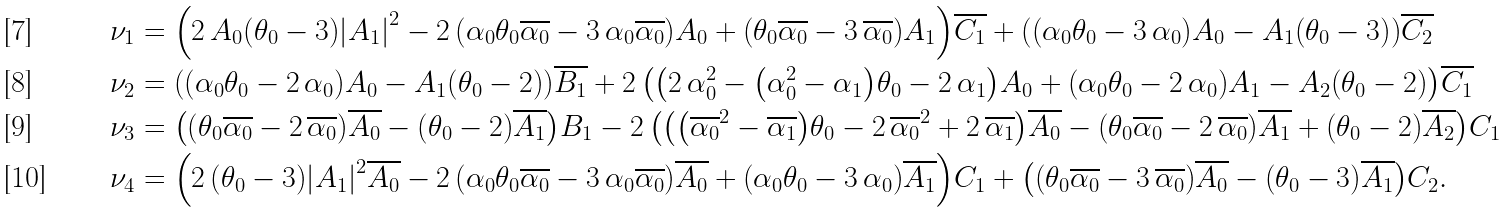<formula> <loc_0><loc_0><loc_500><loc_500>\nu _ { 1 } & = { \left ( 2 \, A _ { 0 } { \left ( \theta _ { 0 } - 3 \right ) } { \left | A _ { 1 } \right | } ^ { 2 } - 2 \, { \left ( \alpha _ { 0 } \theta _ { 0 } \overline { \alpha _ { 0 } } - 3 \, \alpha _ { 0 } \overline { \alpha _ { 0 } } \right ) } A _ { 0 } + { \left ( \theta _ { 0 } \overline { \alpha _ { 0 } } - 3 \, \overline { \alpha _ { 0 } } \right ) } A _ { 1 } \right ) } \overline { C _ { 1 } } + { \left ( { \left ( \alpha _ { 0 } \theta _ { 0 } - 3 \, \alpha _ { 0 } \right ) } A _ { 0 } - A _ { 1 } { \left ( \theta _ { 0 } - 3 \right ) } \right ) } \overline { C _ { 2 } } \\ \nu _ { 2 } & = { \left ( { \left ( \alpha _ { 0 } \theta _ { 0 } - 2 \, \alpha _ { 0 } \right ) } A _ { 0 } - A _ { 1 } { \left ( \theta _ { 0 } - 2 \right ) } \right ) } \overline { B _ { 1 } } + 2 \, { \left ( { \left ( 2 \, \alpha _ { 0 } ^ { 2 } - { \left ( \alpha _ { 0 } ^ { 2 } - \alpha _ { 1 } \right ) } \theta _ { 0 } - 2 \, \alpha _ { 1 } \right ) } A _ { 0 } + { \left ( \alpha _ { 0 } \theta _ { 0 } - 2 \, \alpha _ { 0 } \right ) } A _ { 1 } - A _ { 2 } { \left ( \theta _ { 0 } - 2 \right ) } \right ) } \overline { C _ { 1 } } \\ \nu _ { 3 } & = { \left ( { \left ( \theta _ { 0 } \overline { \alpha _ { 0 } } - 2 \, \overline { \alpha _ { 0 } } \right ) } \overline { A _ { 0 } } - { \left ( \theta _ { 0 } - 2 \right ) } \overline { A _ { 1 } } \right ) } B _ { 1 } - 2 \, { \left ( { \left ( { \left ( \overline { \alpha _ { 0 } } ^ { 2 } - \overline { \alpha _ { 1 } } \right ) } \theta _ { 0 } - 2 \, \overline { \alpha _ { 0 } } ^ { 2 } + 2 \, \overline { \alpha _ { 1 } } \right ) } \overline { A _ { 0 } } - { \left ( \theta _ { 0 } \overline { \alpha _ { 0 } } - 2 \, \overline { \alpha _ { 0 } } \right ) } \overline { A _ { 1 } } + { \left ( \theta _ { 0 } - 2 \right ) } \overline { A _ { 2 } } \right ) } C _ { 1 } \\ \nu _ { 4 } & = { \left ( 2 \, { \left ( \theta _ { 0 } - 3 \right ) } { \left | A _ { 1 } \right | } ^ { 2 } \overline { A _ { 0 } } - 2 \, { \left ( \alpha _ { 0 } \theta _ { 0 } \overline { \alpha _ { 0 } } - 3 \, \alpha _ { 0 } \overline { \alpha _ { 0 } } \right ) } \overline { A _ { 0 } } + { \left ( \alpha _ { 0 } \theta _ { 0 } - 3 \, \alpha _ { 0 } \right ) } \overline { A _ { 1 } } \right ) } C _ { 1 } + { \left ( { \left ( \theta _ { 0 } \overline { \alpha _ { 0 } } - 3 \, \overline { \alpha _ { 0 } } \right ) } \overline { A _ { 0 } } - { \left ( \theta _ { 0 } - 3 \right ) } \overline { A _ { 1 } } \right ) } C _ { 2 } .</formula> 